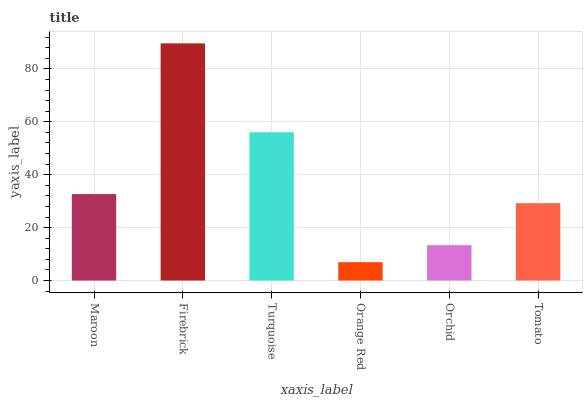Is Orange Red the minimum?
Answer yes or no. Yes. Is Firebrick the maximum?
Answer yes or no. Yes. Is Turquoise the minimum?
Answer yes or no. No. Is Turquoise the maximum?
Answer yes or no. No. Is Firebrick greater than Turquoise?
Answer yes or no. Yes. Is Turquoise less than Firebrick?
Answer yes or no. Yes. Is Turquoise greater than Firebrick?
Answer yes or no. No. Is Firebrick less than Turquoise?
Answer yes or no. No. Is Maroon the high median?
Answer yes or no. Yes. Is Tomato the low median?
Answer yes or no. Yes. Is Tomato the high median?
Answer yes or no. No. Is Orange Red the low median?
Answer yes or no. No. 